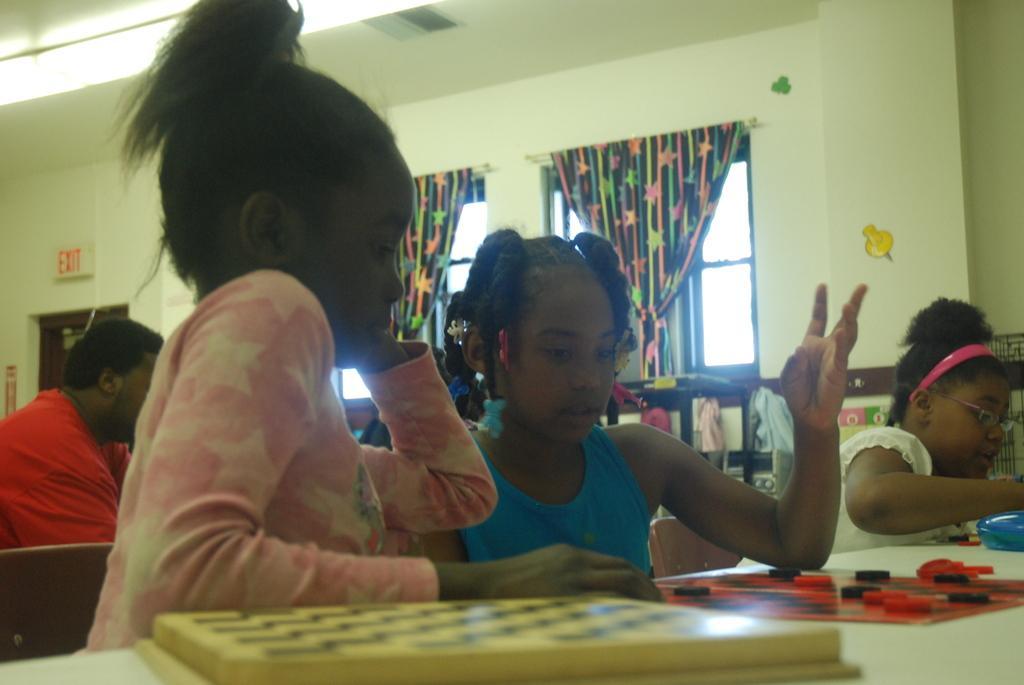In one or two sentences, can you explain what this image depicts? In this image In the middle there is a girl her hair is short. On the left there is a girl her hair is short she wears pink dress. In front of them there is a table on that there are coins. On the right there is a girl she wears white dress. In the background there are some people, window, curtain and wall. 